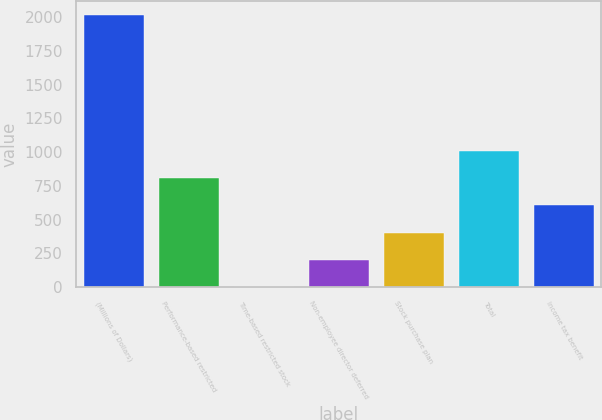Convert chart. <chart><loc_0><loc_0><loc_500><loc_500><bar_chart><fcel>(Millions of Dollars)<fcel>Performance-based restricted<fcel>Time-based restricted stock<fcel>Non-employee director deferred<fcel>Stock purchase plan<fcel>Total<fcel>Income tax benefit<nl><fcel>2015<fcel>806.6<fcel>1<fcel>202.4<fcel>403.8<fcel>1008<fcel>605.2<nl></chart> 